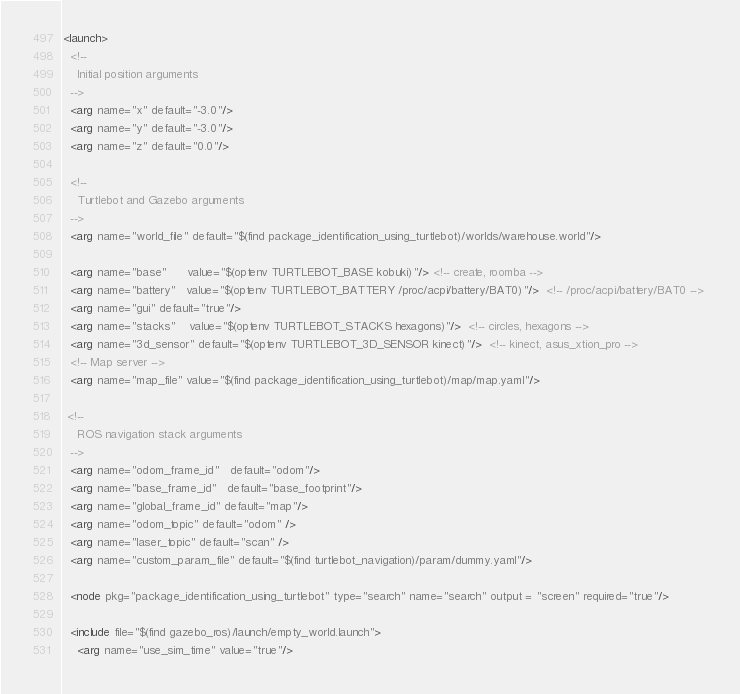<code> <loc_0><loc_0><loc_500><loc_500><_XML_><launch>
  <!-- 
    Initial position arguments
  -->
  <arg name="x" default="-3.0"/>
  <arg name="y" default="-3.0"/>
  <arg name="z" default="0.0"/>

  <!-- 
    Turtlebot and Gazebo arguments
  -->
  <arg name="world_file" default="$(find package_identification_using_turtlebot)/worlds/warehouse.world"/>
  
  <arg name="base"      value="$(optenv TURTLEBOT_BASE kobuki)"/> <!-- create, roomba -->
  <arg name="battery"   value="$(optenv TURTLEBOT_BATTERY /proc/acpi/battery/BAT0)"/>  <!-- /proc/acpi/battery/BAT0 --> 
  <arg name="gui" default="true"/>
  <arg name="stacks"    value="$(optenv TURTLEBOT_STACKS hexagons)"/>  <!-- circles, hexagons --> 
  <arg name="3d_sensor" default="$(optenv TURTLEBOT_3D_SENSOR kinect)"/>  <!-- kinect, asus_xtion_pro --> 
  <!-- Map server -->
  <arg name="map_file" value="$(find package_identification_using_turtlebot)/map/map.yaml"/>
 
 <!-- 
    ROS navigation stack arguments
  -->
  <arg name="odom_frame_id"   default="odom"/>
  <arg name="base_frame_id"   default="base_footprint"/>
  <arg name="global_frame_id" default="map"/>
  <arg name="odom_topic" default="odom" />
  <arg name="laser_topic" default="scan" />
  <arg name="custom_param_file" default="$(find turtlebot_navigation)/param/dummy.yaml"/>
  
  <node pkg="package_identification_using_turtlebot" type="search" name="search" output = "screen" required="true"/>
  
  <include file="$(find gazebo_ros)/launch/empty_world.launch">
    <arg name="use_sim_time" value="true"/></code> 